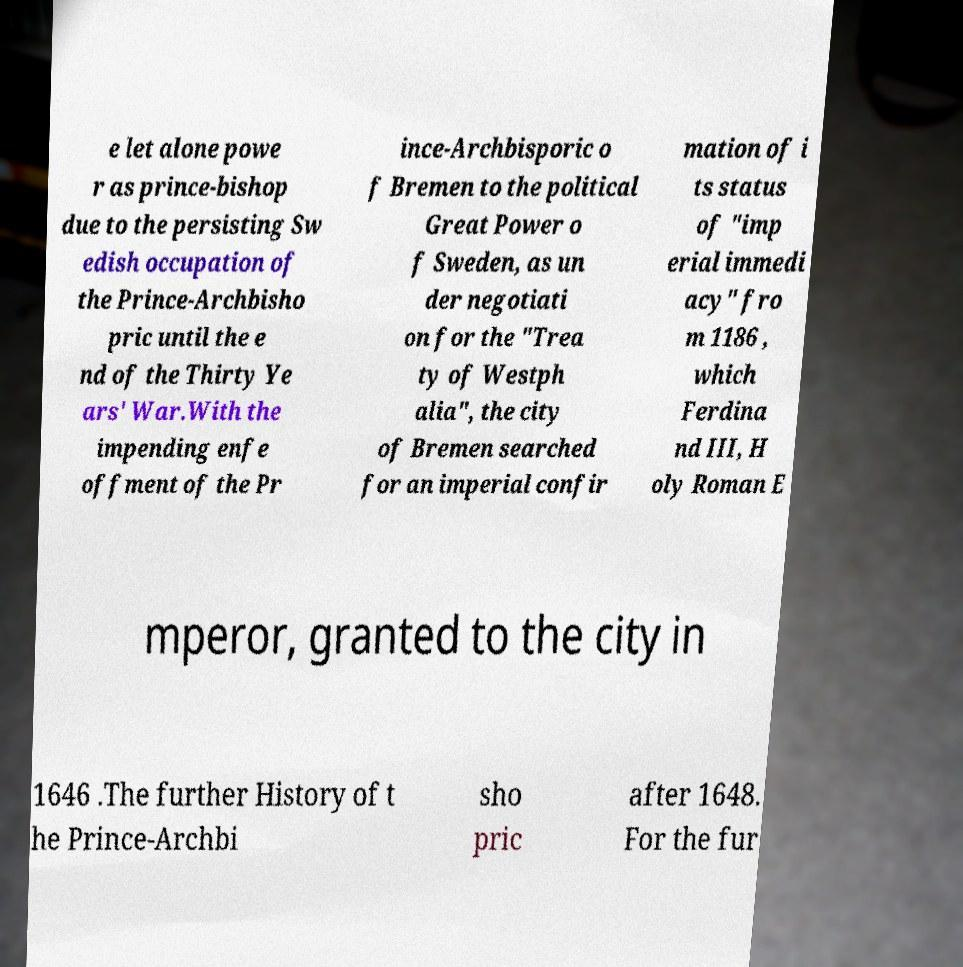Could you extract and type out the text from this image? e let alone powe r as prince-bishop due to the persisting Sw edish occupation of the Prince-Archbisho pric until the e nd of the Thirty Ye ars' War.With the impending enfe offment of the Pr ince-Archbisporic o f Bremen to the political Great Power o f Sweden, as un der negotiati on for the "Trea ty of Westph alia", the city of Bremen searched for an imperial confir mation of i ts status of "imp erial immedi acy" fro m 1186 , which Ferdina nd III, H oly Roman E mperor, granted to the city in 1646 .The further History of t he Prince-Archbi sho pric after 1648. For the fur 